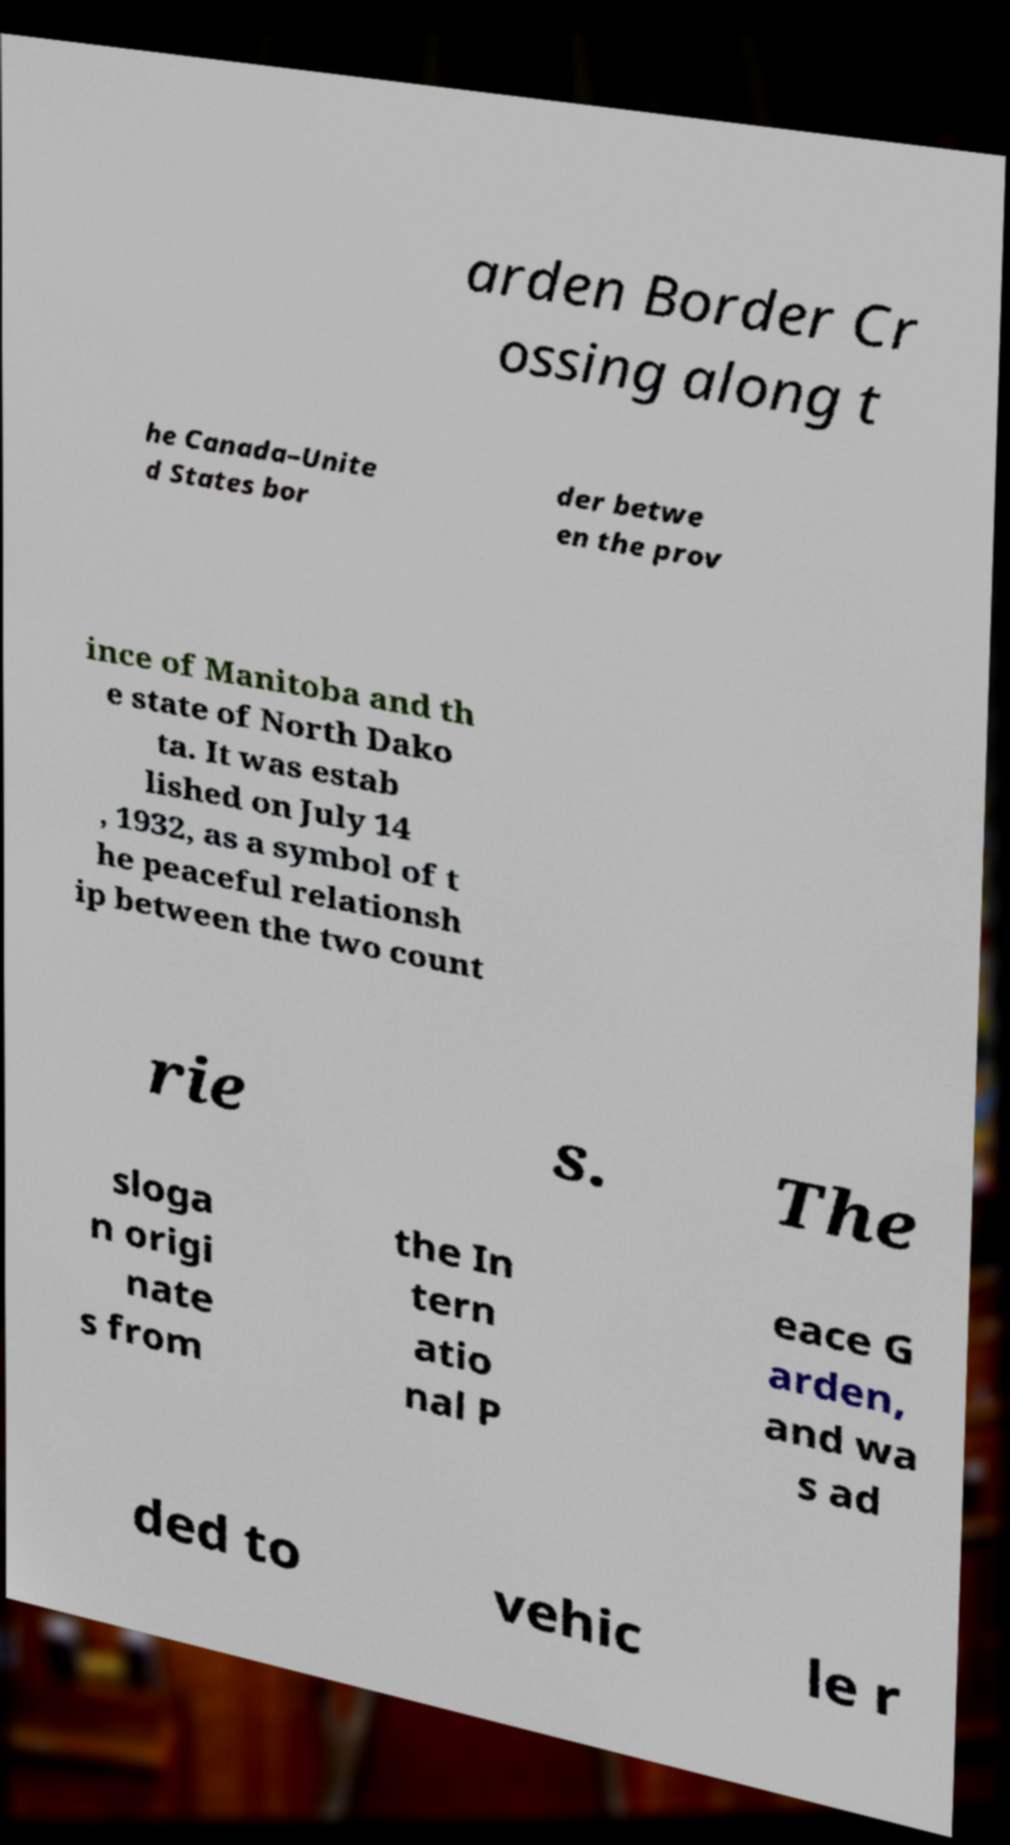For documentation purposes, I need the text within this image transcribed. Could you provide that? arden Border Cr ossing along t he Canada–Unite d States bor der betwe en the prov ince of Manitoba and th e state of North Dako ta. It was estab lished on July 14 , 1932, as a symbol of t he peaceful relationsh ip between the two count rie s. The sloga n origi nate s from the In tern atio nal P eace G arden, and wa s ad ded to vehic le r 